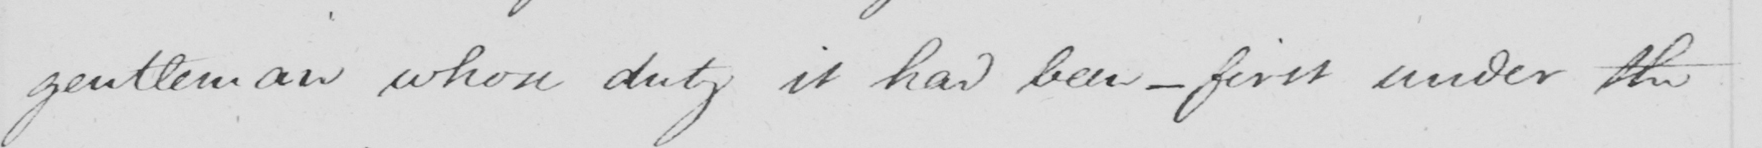Can you read and transcribe this handwriting? gentleman whose duty it had been  _  first under the 